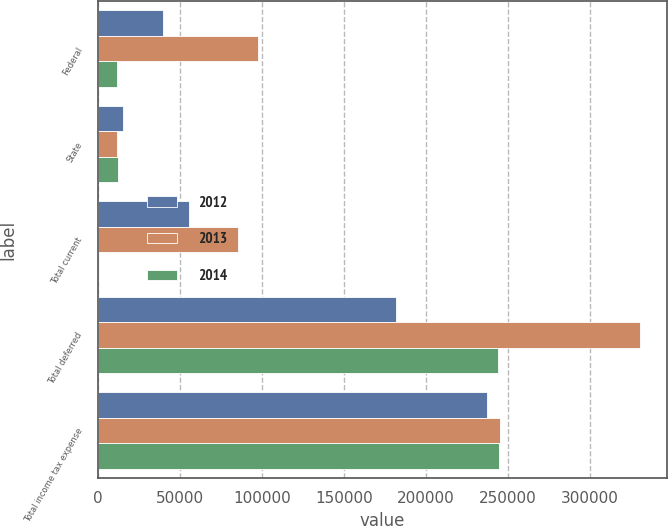<chart> <loc_0><loc_0><loc_500><loc_500><stacked_bar_chart><ecel><fcel>Federal<fcel>State<fcel>Total current<fcel>Total deferred<fcel>Total income tax expense<nl><fcel>2012<fcel>40115<fcel>15598<fcel>55713<fcel>181647<fcel>237360<nl><fcel>2013<fcel>97531<fcel>11983<fcel>85548<fcel>330643<fcel>245095<nl><fcel>2014<fcel>11650<fcel>12308<fcel>658<fcel>243738<fcel>244396<nl></chart> 